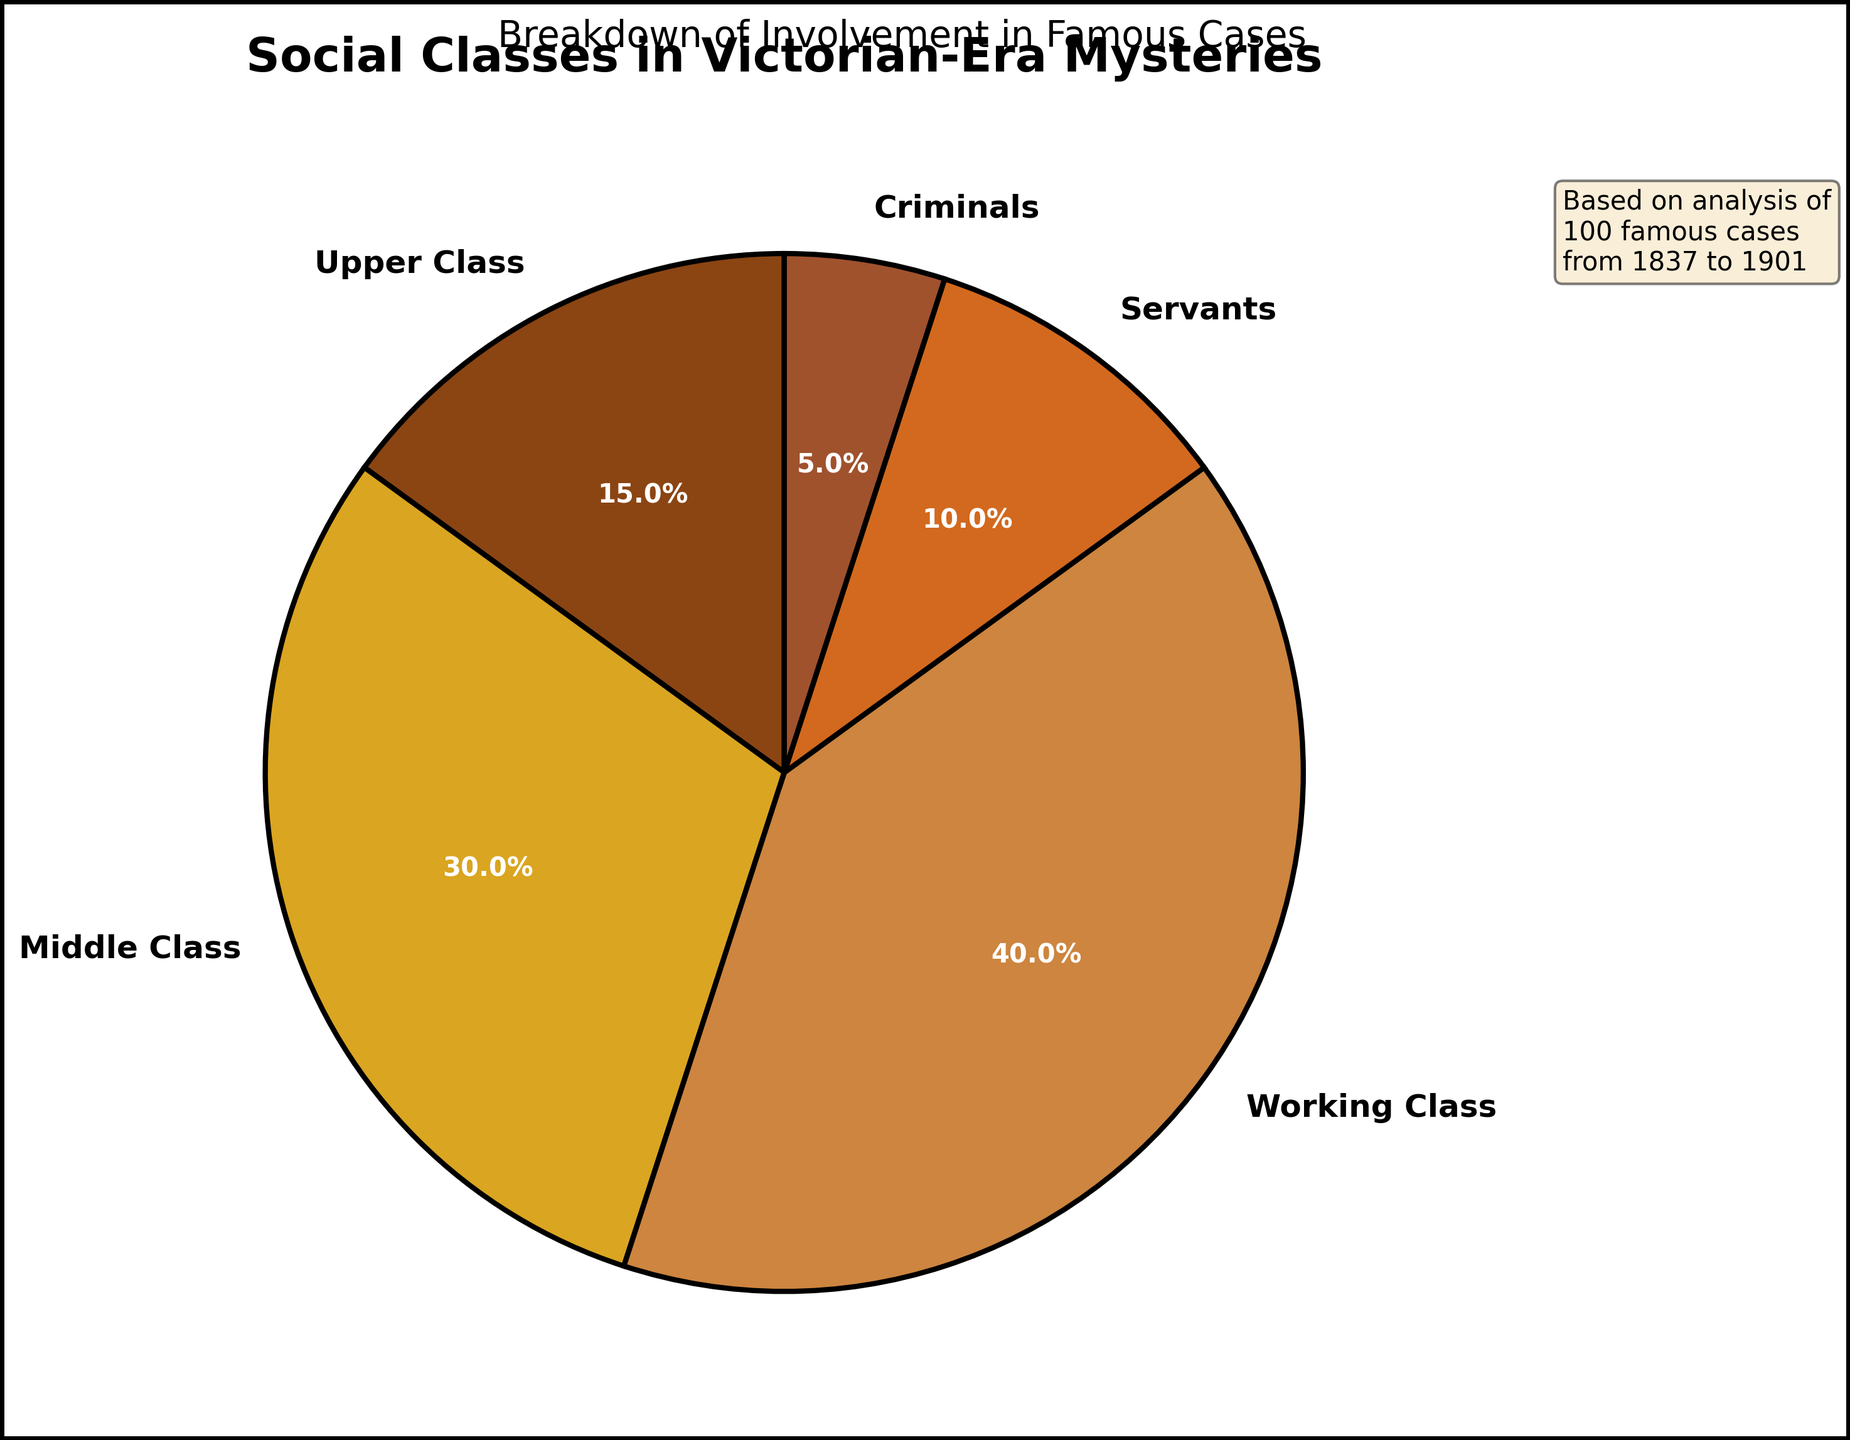What percentage of the social classes involved in famous Victorian-era mysteries belong to the working class? To find the percentage of the working class, refer to the pie chart where each slice is labeled with the respective class and percentage. The working class slice shows a percentage of 40%.
Answer: 40% Which social class has the smallest representation in the chart? To determine the class with the smallest representation, compare the percentages of each class as labeled on the pie chart. Criminals have the smallest percentage at 5%.
Answer: Criminals What is the combined percentage of the middle class and upper class? Sum the percentages of the middle class and upper class as shown in the pie chart. The middle class is 30% and the upper class is 15%, so 30% + 15% = 45%.
Answer: 45% How does the percentage of servants compare to that of the working class? Compare the labeled percentages of servants and working class in the pie chart. Servants are 10% while the working class is 40%. Therefore, servants have a smaller percentage than the working class.
Answer: Smaller Which class is shown with the second largest percentage? Observe the labeled percentages in the pie chart to identify the second largest. The working class is the largest at 40%, and the middle class is the second largest at 30%.
Answer: Middle Class What is the difference in percentage points between the middle class and the criminals? Subtract the percentage of criminals from that of the middle class. The middle class is 30% and criminals are 5%, so 30% - 5% = 25%.
Answer: 25% How do the total percentages of the upper class and servants combined compare to the working class? Sum the percentages of the upper class and servants and then compare it to the percentage of the working class. Upper class is 15% + servants 10% = 25%, which is less than the working class percentage of 40%.
Answer: Less What percentage of social classes involved in Victorian-era mysteries belong neither to the middle nor the working class? Subtract the combined percentage of the middle and working class from 100%. Middle class is 30% and working class is 40%, so (30% + 40%) = 70%. Then, 100% - 70% = 30%.
Answer: 30% What percentage of the total cases were not associated with the working class? Subtract the percentage of the working class from 100%. The working class is 40%, so 100% - 40% = 60%.
Answer: 60% What is the sum of the percentages for the upper class, middle class, and criminals? Add the percentages of the upper class, middle class, and criminals. Upper class is 15%, middle class is 30%, and criminals are 5%, so 15% + 30% + 5% = 50%.
Answer: 50% 